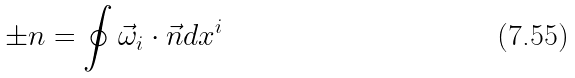Convert formula to latex. <formula><loc_0><loc_0><loc_500><loc_500>\pm n = \oint \vec { \omega } _ { i } \cdot \vec { n } d x ^ { i }</formula> 